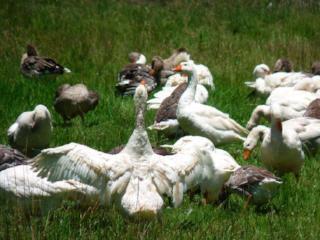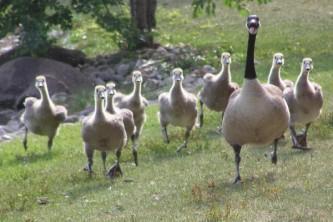The first image is the image on the left, the second image is the image on the right. Assess this claim about the two images: "An image includes at least one long-necked goose with a black neck, and the goose is upright on the grass.". Correct or not? Answer yes or no. Yes. The first image is the image on the left, the second image is the image on the right. Analyze the images presented: Is the assertion "One of the images show geese that are all facing left." valid? Answer yes or no. No. 